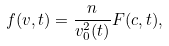Convert formula to latex. <formula><loc_0><loc_0><loc_500><loc_500>f ( { v } , t ) = \frac { n } { v _ { 0 } ^ { 2 } ( t ) } F ( { c } , t ) ,</formula> 